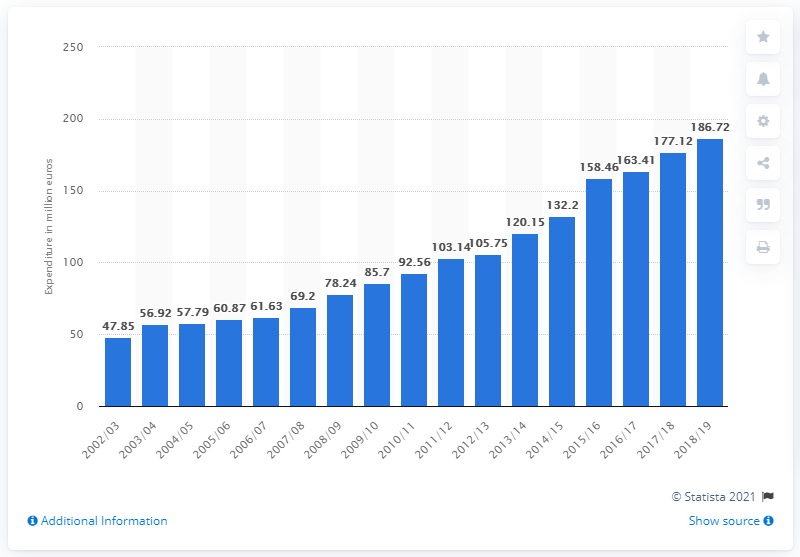Outline some significant characteristics in this image. The German Bundesliga clubs collectively spent 186.72 million euros on their youth academies during the 2018/19 season. In the 2002/03 season, the 36 clubs of the German Bundesliga spent the most on their youth academies. 